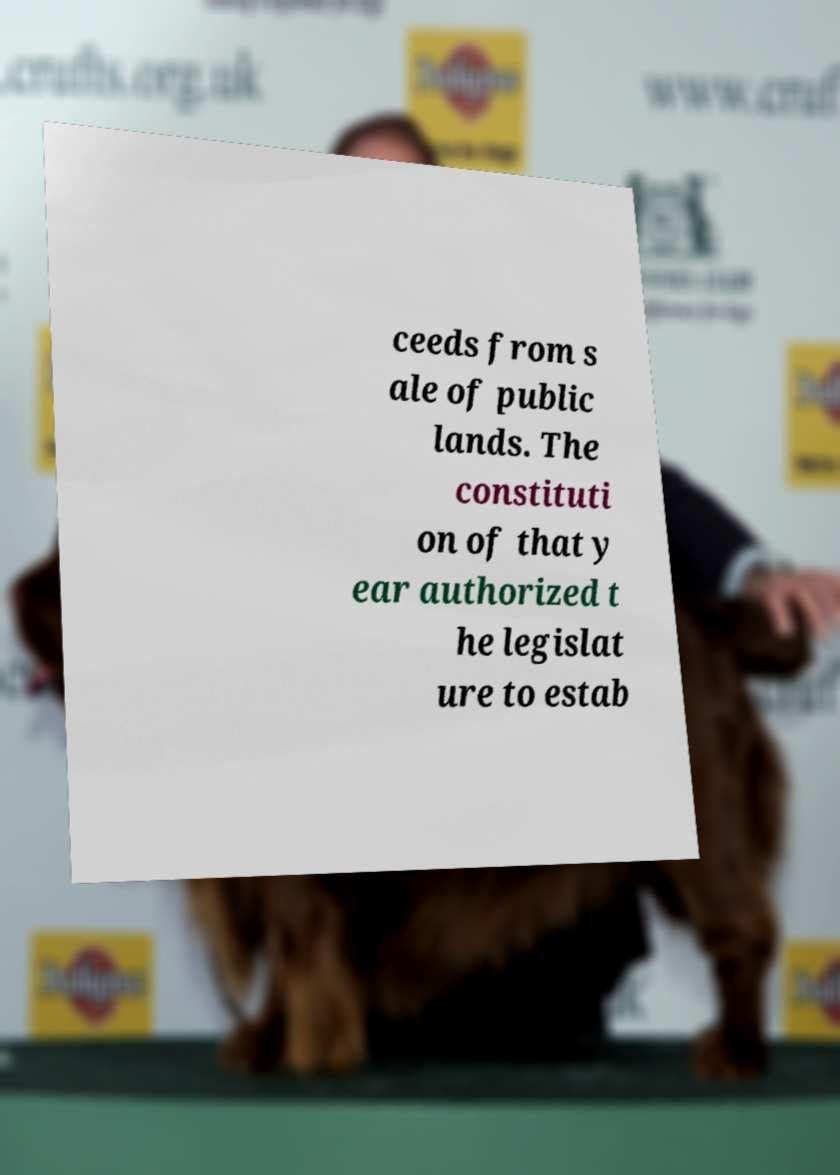Please identify and transcribe the text found in this image. ceeds from s ale of public lands. The constituti on of that y ear authorized t he legislat ure to estab 